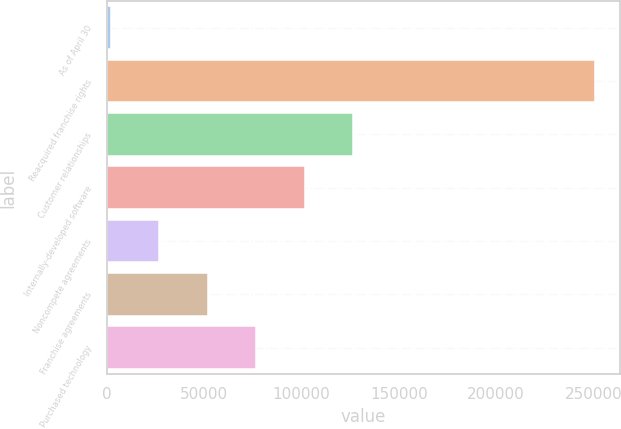Convert chart. <chart><loc_0><loc_0><loc_500><loc_500><bar_chart><fcel>As of April 30<fcel>Reacquired franchise rights<fcel>Customer relationships<fcel>Internally-developed software<fcel>Noncompete agreements<fcel>Franchise agreements<fcel>Purchased technology<nl><fcel>2016<fcel>251070<fcel>126543<fcel>101638<fcel>26921.4<fcel>51826.8<fcel>76732.2<nl></chart> 